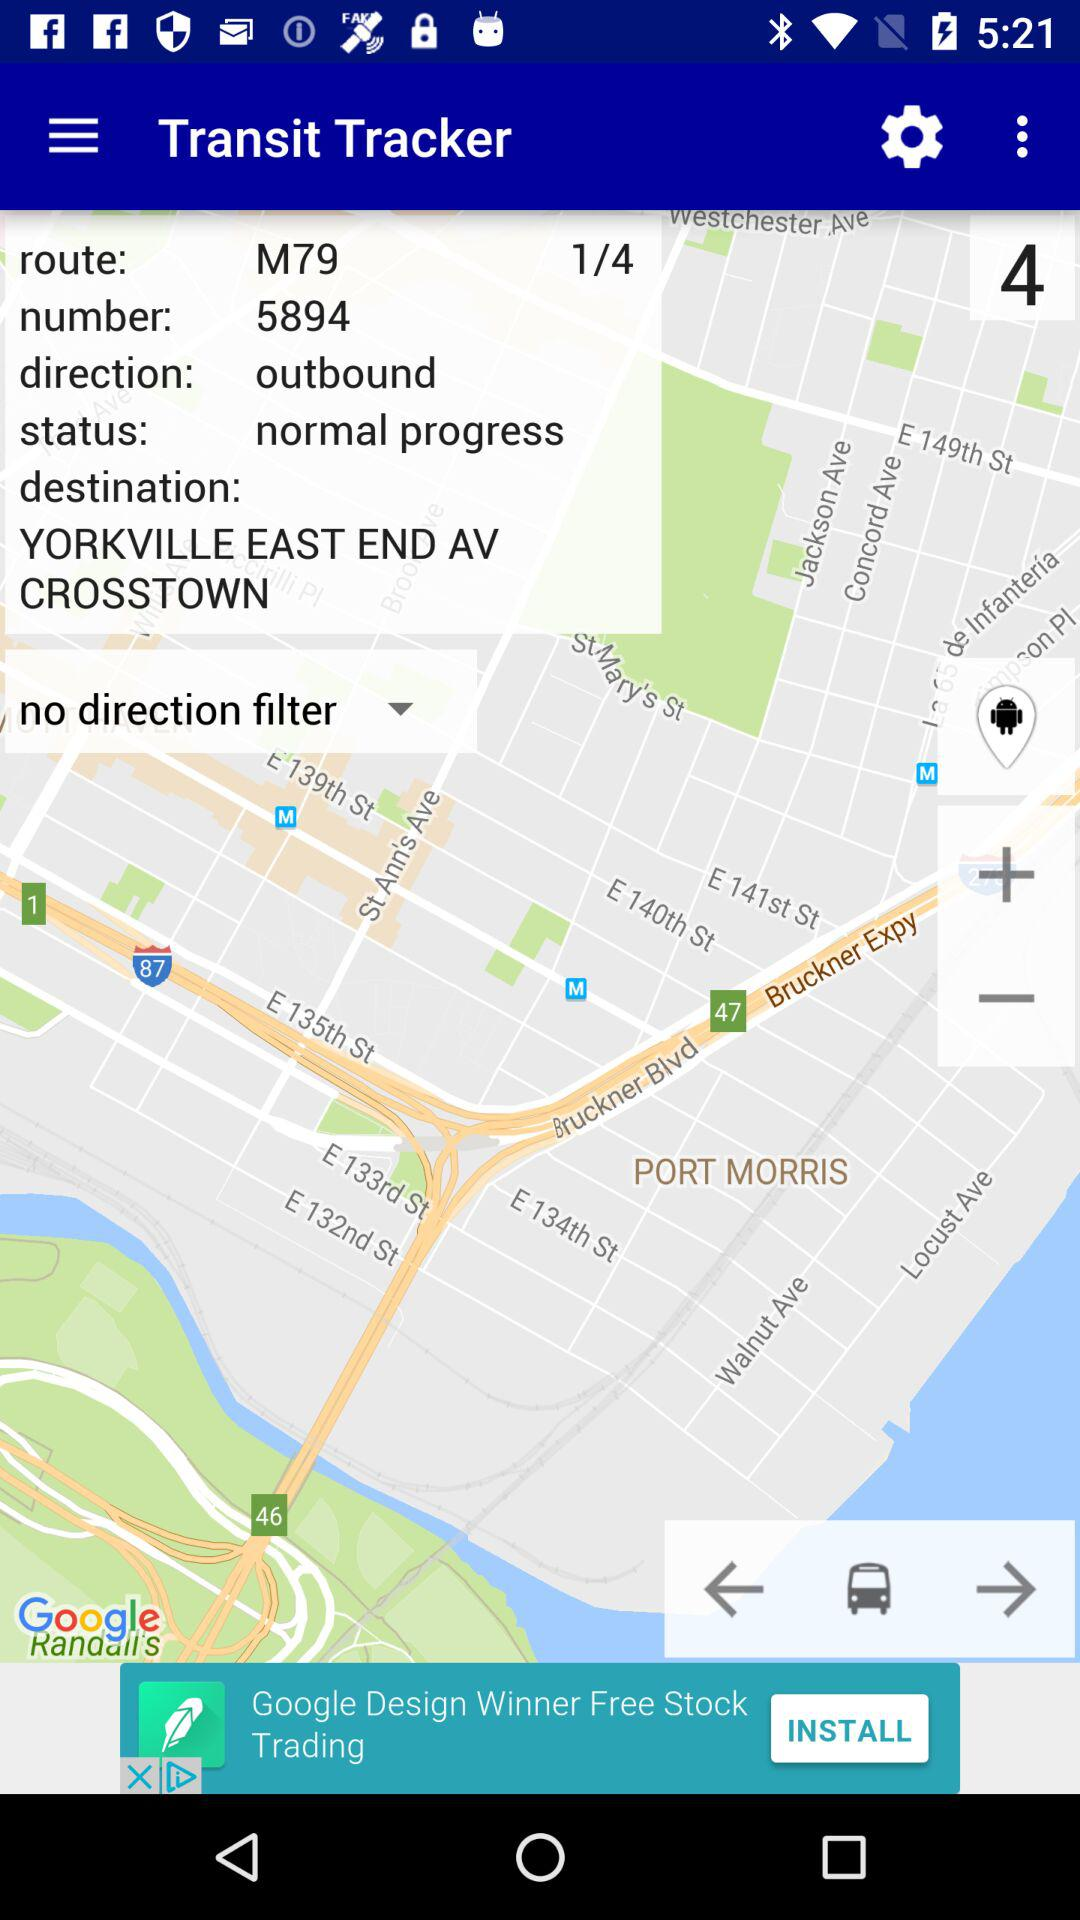What is the destination of the route?
Answer the question using a single word or phrase. YORKVILLE EAST END AV CROSSTOWN P 